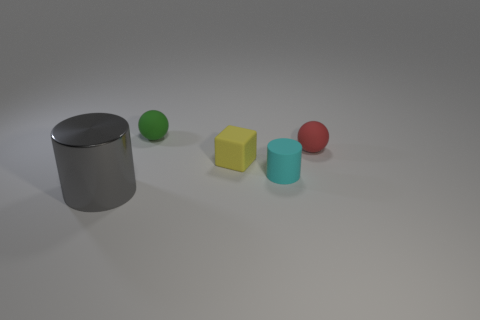Add 1 cyan cylinders. How many objects exist? 6 Subtract all cylinders. How many objects are left? 3 Add 1 green matte objects. How many green matte objects are left? 2 Add 5 cyan cylinders. How many cyan cylinders exist? 6 Subtract 1 green balls. How many objects are left? 4 Subtract all red balls. Subtract all cylinders. How many objects are left? 2 